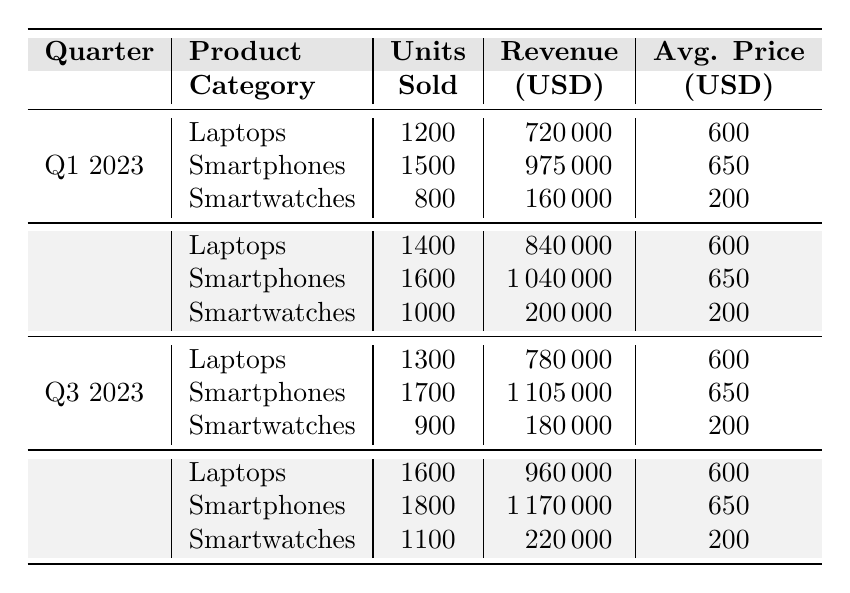What was the total revenue from Smartphones in Q3 2023? In Q3 2023, the revenue from Smartphones is listed as 1,105,000 USD. There are no calculations needed as this value can be directly retrieved from the table.
Answer: 1,105,000 USD Which product category had the highest average price in Q2 2023? In Q2 2023, Laptops and Smartphones both have an average price of 600 USD and 650 USD respectively, while Smartwatches have an average price of 200 USD. Comparing these values, Smartphones have the highest average price of 650 USD.
Answer: Smartphones What was the change in units sold for Laptops from Q1 2023 to Q4 2023? The number of units sold for Laptops in Q1 2023 is 1,200 and in Q4 2023 is 1,600. The change can be calculated as 1,600 - 1,200 = 400 units.
Answer: 400 units What is the total number of units sold across all product categories in Q2 2023? In Q2 2023, Laptops sold 1,400 units, Smartphones sold 1,600 units, and Smartwatches sold 1,000 units. Summing them gives 1,400 + 1,600 + 1,000 = 4,000 units sold.
Answer: 4,000 units Did Smartwatches generate more revenue in Q1 2023 than in Q2 2023? The revenue from Smartwatches in Q1 2023 is 160,000 USD, while in Q2 2023 it is 200,000 USD. Since 160,000 is less than 200,000, the answer is no.
Answer: No What is the average number of units sold for Smartphones across all quarters in 2023? The units sold for Smartphones were: Q1 - 1,500, Q2 - 1,600, Q3 - 1,700, and Q4 - 1,800. Summing these gives 1,500 + 1,600 + 1,700 + 1,800 = 6,600 units. Dividing by the number of quarters (4), the average is 6,600 / 4 = 1,650 units.
Answer: 1,650 units Which quarter showed the highest revenue from Laptops? The revenue for Laptops for each quarter is: Q1 - 720,000, Q2 - 840,000, Q3 - 780,000, and Q4 - 960,000. Out of these values, the highest revenue is 960,000 USD in Q4 2023.
Answer: Q4 2023 What percentage of total sales units in Q3 2023 were Smartwatches? In Q3 2023, the total units sold were: Laptops (1,300), Smartphones (1,700), and Smartwatches (900). The total is 1,300 + 1,700 + 900 = 3,900 units. The percentage of Smartwatches is (900 / 3,900) * 100 ≈ 23.08%.
Answer: 23.08% Which product category consistently sold 1,600 units or more every quarter? By examining the units sold for each product category: Laptops sold 1,200, 1,400, 1,300, and 1,600 units; Smartphones sold 1,500, 1,600, 1,700, and 1,800 units; Smartwatches sold 800, 1,000, 900, and 1,100 units. Only Smartphones sold 1,600 units or more in all four quarters.
Answer: Smartphones 